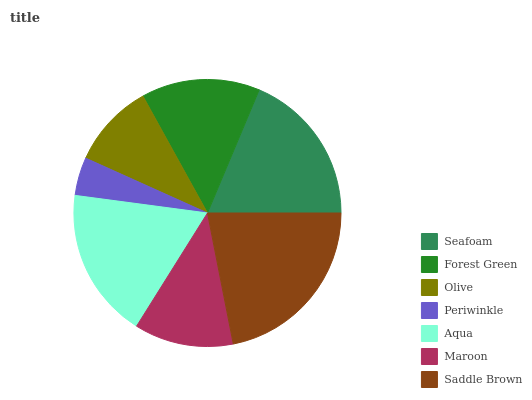Is Periwinkle the minimum?
Answer yes or no. Yes. Is Saddle Brown the maximum?
Answer yes or no. Yes. Is Forest Green the minimum?
Answer yes or no. No. Is Forest Green the maximum?
Answer yes or no. No. Is Seafoam greater than Forest Green?
Answer yes or no. Yes. Is Forest Green less than Seafoam?
Answer yes or no. Yes. Is Forest Green greater than Seafoam?
Answer yes or no. No. Is Seafoam less than Forest Green?
Answer yes or no. No. Is Forest Green the high median?
Answer yes or no. Yes. Is Forest Green the low median?
Answer yes or no. Yes. Is Periwinkle the high median?
Answer yes or no. No. Is Periwinkle the low median?
Answer yes or no. No. 